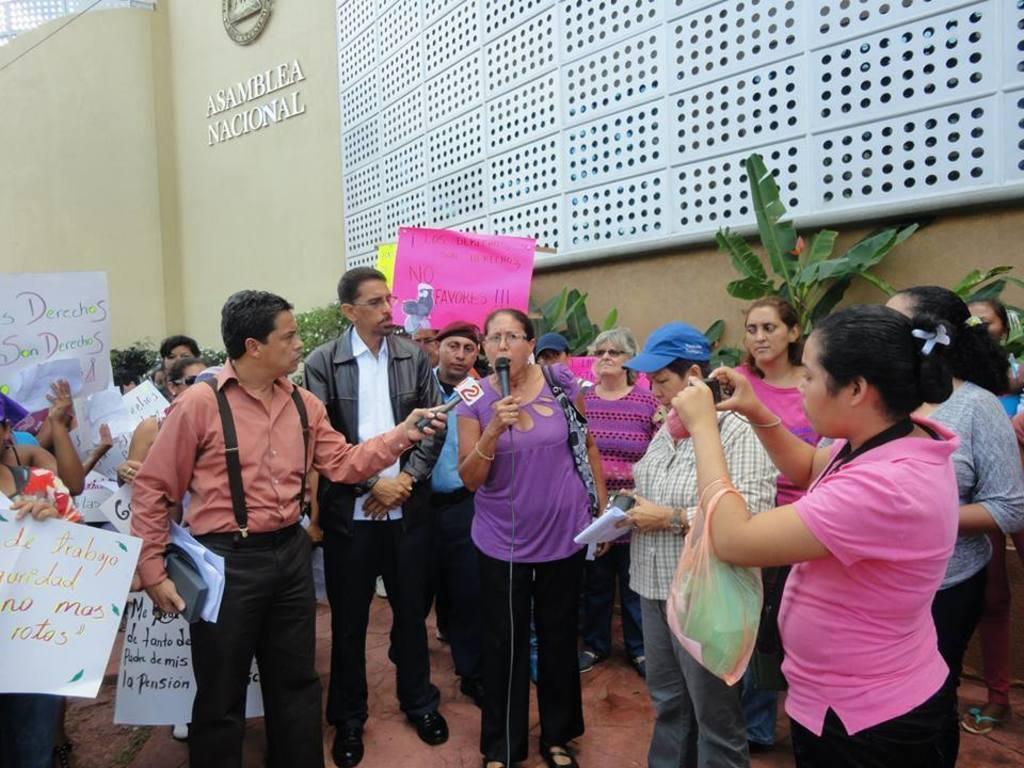Please provide a concise description of this image. In this picture we can see a group of people standing and two people holding the microphones and a woman is holding an object. Some people holding the papers and on the right side of the people there are plants and behind the people there is a wall with a name board, logo and an object. 